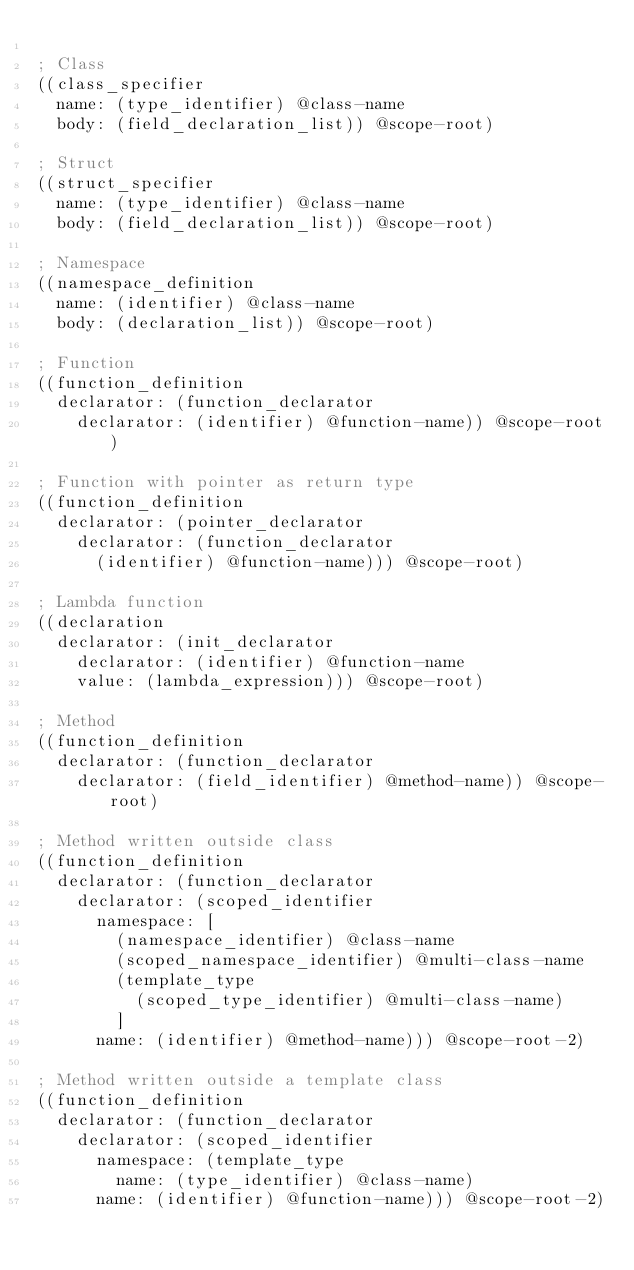Convert code to text. <code><loc_0><loc_0><loc_500><loc_500><_Scheme_>
; Class
((class_specifier
	name: (type_identifier) @class-name
	body: (field_declaration_list)) @scope-root)

; Struct
((struct_specifier
	name: (type_identifier) @class-name
	body: (field_declaration_list)) @scope-root)

; Namespace
((namespace_definition
	name: (identifier) @class-name
	body: (declaration_list)) @scope-root)

; Function
((function_definition
	declarator: (function_declarator
		declarator: (identifier) @function-name)) @scope-root)

; Function with pointer as return type
((function_definition
	declarator: (pointer_declarator
		declarator: (function_declarator
			(identifier) @function-name))) @scope-root)

; Lambda function
((declaration
	declarator: (init_declarator
		declarator: (identifier) @function-name
		value: (lambda_expression))) @scope-root)

; Method
((function_definition
	declarator: (function_declarator
		declarator: (field_identifier) @method-name)) @scope-root)

; Method written outside class
((function_definition
	declarator: (function_declarator
		declarator: (scoped_identifier
			namespace: [
				(namespace_identifier) @class-name
				(scoped_namespace_identifier) @multi-class-name
				(template_type
					(scoped_type_identifier) @multi-class-name)
				]
			name: (identifier) @method-name))) @scope-root-2)

; Method written outside a template class
((function_definition
	declarator: (function_declarator
		declarator: (scoped_identifier
			namespace: (template_type
				name: (type_identifier) @class-name)
			name: (identifier) @function-name))) @scope-root-2)
</code> 